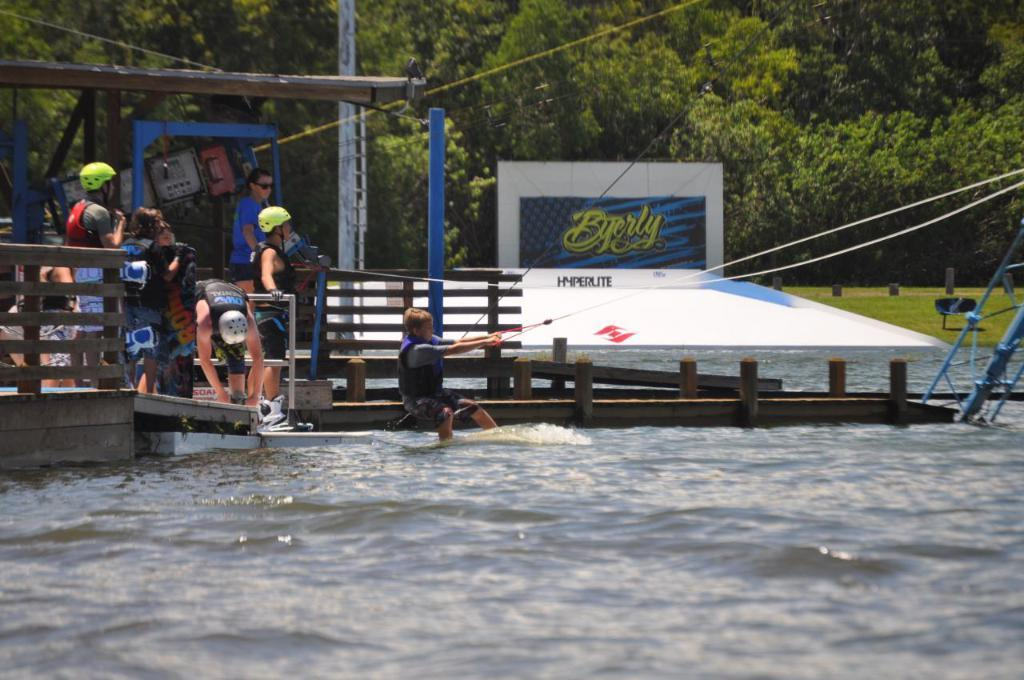<image>
Write a terse but informative summary of the picture. A water scene with a sign at the back that says Byerly. 